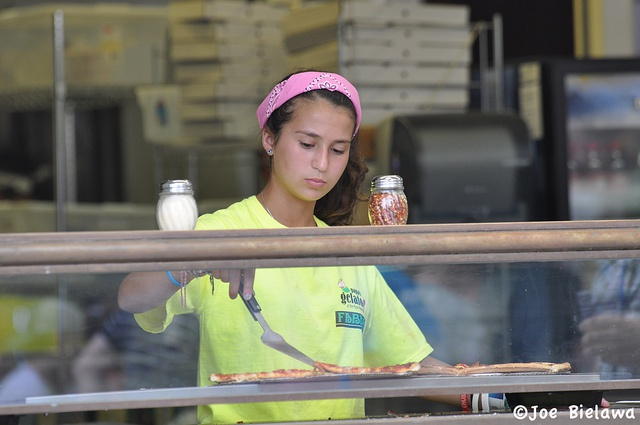Describe the objects in this image and their specific colors. I can see people in black, khaki, tan, gray, and darkgray tones, refrigerator in black and gray tones, tv in black and gray tones, pizza in black, tan, darkgray, and gray tones, and knife in black, darkgray, khaki, lightgreen, and gray tones in this image. 